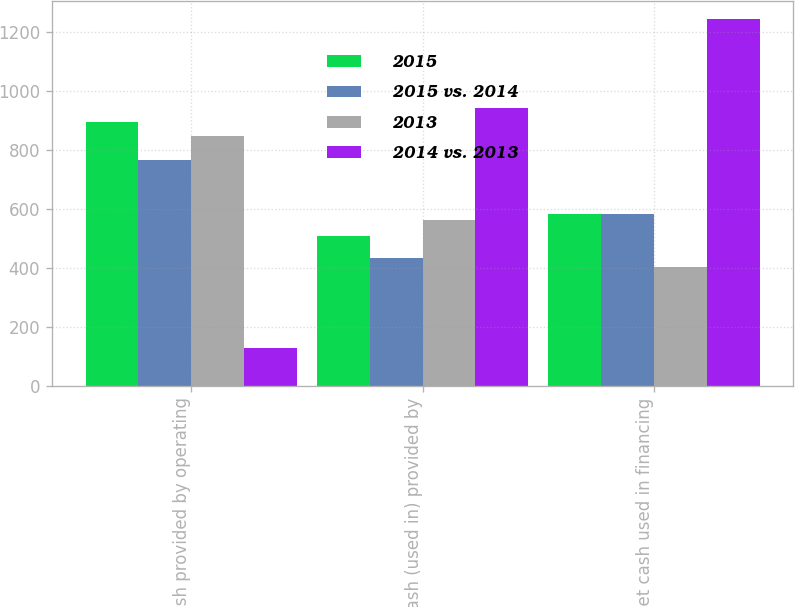Convert chart. <chart><loc_0><loc_0><loc_500><loc_500><stacked_bar_chart><ecel><fcel>Net cash provided by operating<fcel>Net cash (used in) provided by<fcel>Net cash used in financing<nl><fcel>2015<fcel>892.5<fcel>508.7<fcel>581.4<nl><fcel>2015 vs. 2014<fcel>763.4<fcel>434<fcel>581.4<nl><fcel>2013<fcel>845.9<fcel>561<fcel>401.7<nl><fcel>2014 vs. 2013<fcel>129.1<fcel>942.7<fcel>1242.8<nl></chart> 